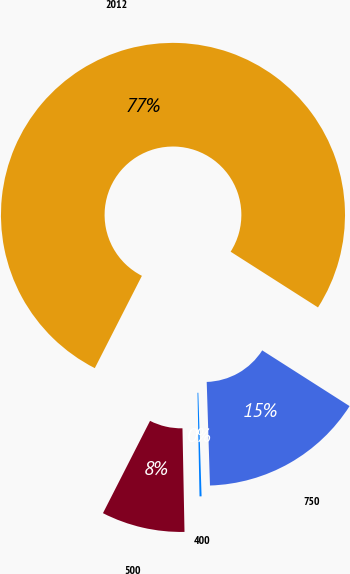Convert chart to OTSL. <chart><loc_0><loc_0><loc_500><loc_500><pie_chart><fcel>2012<fcel>500<fcel>400<fcel>750<nl><fcel>76.53%<fcel>7.82%<fcel>0.19%<fcel>15.46%<nl></chart> 